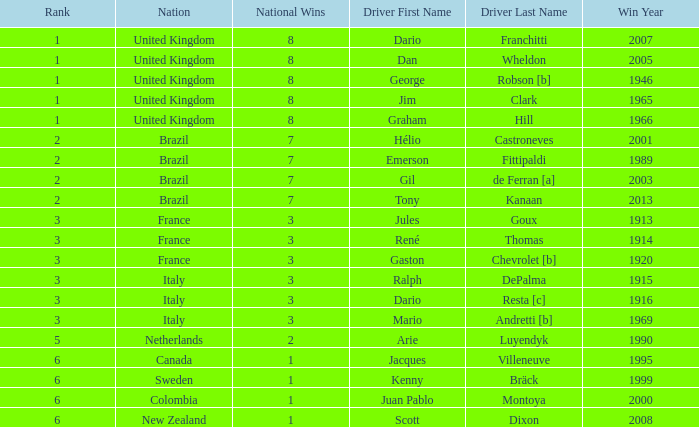What is the average number of wins of drivers from Sweden? 1999.0. Can you parse all the data within this table? {'header': ['Rank', 'Nation', 'National Wins', 'Driver First Name', 'Driver Last Name', 'Win Year'], 'rows': [['1', 'United Kingdom', '8', 'Dario', 'Franchitti', '2007'], ['1', 'United Kingdom', '8', 'Dan', 'Wheldon', '2005'], ['1', 'United Kingdom', '8', 'George', 'Robson [b]', '1946'], ['1', 'United Kingdom', '8', 'Jim', 'Clark', '1965'], ['1', 'United Kingdom', '8', 'Graham', 'Hill', '1966'], ['2', 'Brazil', '7', 'Hélio', 'Castroneves', '2001'], ['2', 'Brazil', '7', 'Emerson', 'Fittipaldi', '1989'], ['2', 'Brazil', '7', 'Gil', 'de Ferran [a]', '2003'], ['2', 'Brazil', '7', 'Tony', 'Kanaan', '2013'], ['3', 'France', '3', 'Jules', 'Goux', '1913'], ['3', 'France', '3', 'René', 'Thomas', '1914'], ['3', 'France', '3', 'Gaston', 'Chevrolet [b]', '1920'], ['3', 'Italy', '3', 'Ralph', 'DePalma', '1915'], ['3', 'Italy', '3', 'Dario', 'Resta [c]', '1916'], ['3', 'Italy', '3', 'Mario', 'Andretti [b]', '1969'], ['5', 'Netherlands', '2', 'Arie', 'Luyendyk', '1990'], ['6', 'Canada', '1', 'Jacques', 'Villeneuve', '1995'], ['6', 'Sweden', '1', 'Kenny', 'Bräck', '1999'], ['6', 'Colombia', '1', 'Juan Pablo', 'Montoya', '2000'], ['6', 'New Zealand', '1', 'Scott', 'Dixon', '2008']]} 